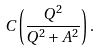<formula> <loc_0><loc_0><loc_500><loc_500>C \left ( \frac { Q ^ { 2 } } { Q ^ { 2 } + A ^ { 2 } } \right ) .</formula> 